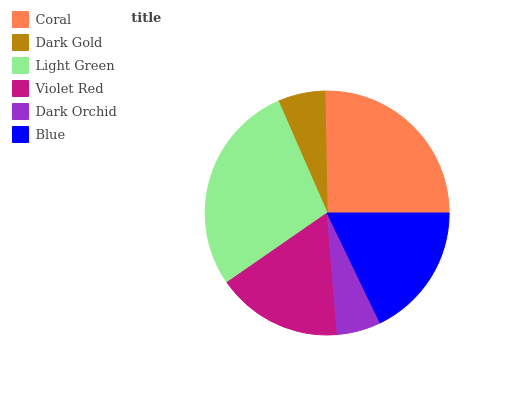Is Dark Orchid the minimum?
Answer yes or no. Yes. Is Light Green the maximum?
Answer yes or no. Yes. Is Dark Gold the minimum?
Answer yes or no. No. Is Dark Gold the maximum?
Answer yes or no. No. Is Coral greater than Dark Gold?
Answer yes or no. Yes. Is Dark Gold less than Coral?
Answer yes or no. Yes. Is Dark Gold greater than Coral?
Answer yes or no. No. Is Coral less than Dark Gold?
Answer yes or no. No. Is Blue the high median?
Answer yes or no. Yes. Is Violet Red the low median?
Answer yes or no. Yes. Is Coral the high median?
Answer yes or no. No. Is Coral the low median?
Answer yes or no. No. 